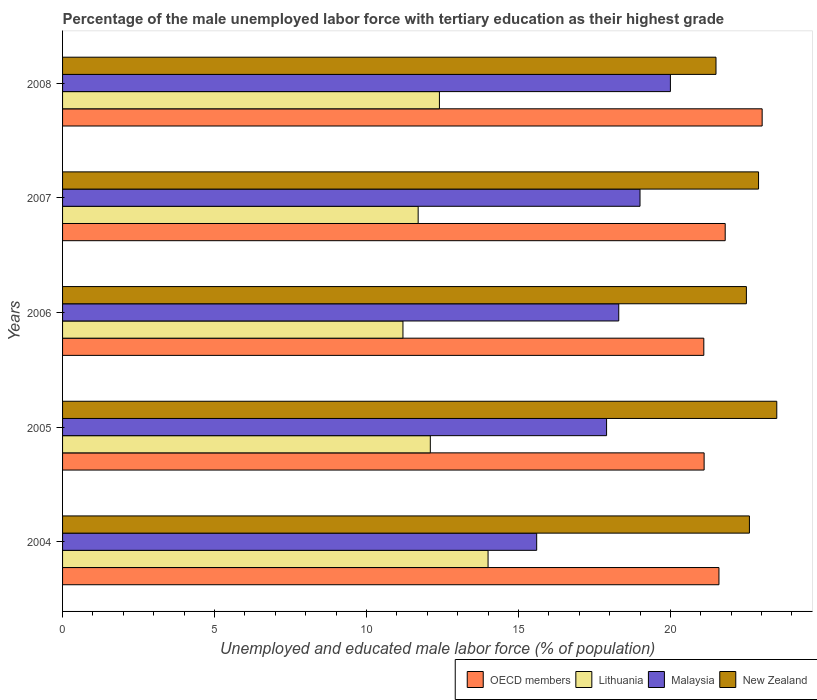How many different coloured bars are there?
Your answer should be compact. 4. Are the number of bars per tick equal to the number of legend labels?
Your response must be concise. Yes. How many bars are there on the 1st tick from the bottom?
Offer a very short reply. 4. What is the label of the 2nd group of bars from the top?
Make the answer very short. 2007. In how many cases, is the number of bars for a given year not equal to the number of legend labels?
Provide a short and direct response. 0. What is the percentage of the unemployed male labor force with tertiary education in Lithuania in 2005?
Provide a succinct answer. 12.1. In which year was the percentage of the unemployed male labor force with tertiary education in New Zealand maximum?
Provide a short and direct response. 2005. In which year was the percentage of the unemployed male labor force with tertiary education in OECD members minimum?
Your answer should be very brief. 2006. What is the total percentage of the unemployed male labor force with tertiary education in New Zealand in the graph?
Ensure brevity in your answer.  113. What is the difference between the percentage of the unemployed male labor force with tertiary education in Malaysia in 2004 and that in 2007?
Provide a succinct answer. -3.4. What is the difference between the percentage of the unemployed male labor force with tertiary education in OECD members in 2008 and the percentage of the unemployed male labor force with tertiary education in Lithuania in 2007?
Offer a terse response. 11.32. What is the average percentage of the unemployed male labor force with tertiary education in New Zealand per year?
Your response must be concise. 22.6. In the year 2005, what is the difference between the percentage of the unemployed male labor force with tertiary education in Lithuania and percentage of the unemployed male labor force with tertiary education in Malaysia?
Your response must be concise. -5.8. What is the ratio of the percentage of the unemployed male labor force with tertiary education in Lithuania in 2004 to that in 2006?
Provide a short and direct response. 1.25. Is the percentage of the unemployed male labor force with tertiary education in Lithuania in 2004 less than that in 2006?
Give a very brief answer. No. Is the difference between the percentage of the unemployed male labor force with tertiary education in Lithuania in 2004 and 2005 greater than the difference between the percentage of the unemployed male labor force with tertiary education in Malaysia in 2004 and 2005?
Provide a short and direct response. Yes. What is the difference between the highest and the second highest percentage of the unemployed male labor force with tertiary education in Lithuania?
Provide a succinct answer. 1.6. What is the difference between the highest and the lowest percentage of the unemployed male labor force with tertiary education in OECD members?
Your answer should be very brief. 1.92. What does the 1st bar from the top in 2006 represents?
Provide a short and direct response. New Zealand. What does the 3rd bar from the bottom in 2008 represents?
Offer a terse response. Malaysia. Are all the bars in the graph horizontal?
Provide a succinct answer. Yes. Are the values on the major ticks of X-axis written in scientific E-notation?
Your response must be concise. No. Does the graph contain any zero values?
Your answer should be very brief. No. Where does the legend appear in the graph?
Give a very brief answer. Bottom right. What is the title of the graph?
Your response must be concise. Percentage of the male unemployed labor force with tertiary education as their highest grade. What is the label or title of the X-axis?
Your answer should be compact. Unemployed and educated male labor force (% of population). What is the label or title of the Y-axis?
Make the answer very short. Years. What is the Unemployed and educated male labor force (% of population) of OECD members in 2004?
Keep it short and to the point. 21.6. What is the Unemployed and educated male labor force (% of population) of Malaysia in 2004?
Provide a succinct answer. 15.6. What is the Unemployed and educated male labor force (% of population) in New Zealand in 2004?
Ensure brevity in your answer.  22.6. What is the Unemployed and educated male labor force (% of population) in OECD members in 2005?
Your answer should be compact. 21.11. What is the Unemployed and educated male labor force (% of population) of Lithuania in 2005?
Provide a succinct answer. 12.1. What is the Unemployed and educated male labor force (% of population) of Malaysia in 2005?
Your answer should be very brief. 17.9. What is the Unemployed and educated male labor force (% of population) in OECD members in 2006?
Keep it short and to the point. 21.1. What is the Unemployed and educated male labor force (% of population) in Lithuania in 2006?
Provide a short and direct response. 11.2. What is the Unemployed and educated male labor force (% of population) of Malaysia in 2006?
Give a very brief answer. 18.3. What is the Unemployed and educated male labor force (% of population) in New Zealand in 2006?
Your answer should be very brief. 22.5. What is the Unemployed and educated male labor force (% of population) in OECD members in 2007?
Provide a short and direct response. 21.8. What is the Unemployed and educated male labor force (% of population) in Lithuania in 2007?
Make the answer very short. 11.7. What is the Unemployed and educated male labor force (% of population) in Malaysia in 2007?
Make the answer very short. 19. What is the Unemployed and educated male labor force (% of population) in New Zealand in 2007?
Keep it short and to the point. 22.9. What is the Unemployed and educated male labor force (% of population) in OECD members in 2008?
Offer a very short reply. 23.02. What is the Unemployed and educated male labor force (% of population) in Lithuania in 2008?
Your answer should be very brief. 12.4. What is the Unemployed and educated male labor force (% of population) in Malaysia in 2008?
Your answer should be compact. 20. Across all years, what is the maximum Unemployed and educated male labor force (% of population) of OECD members?
Provide a succinct answer. 23.02. Across all years, what is the maximum Unemployed and educated male labor force (% of population) in Lithuania?
Your answer should be very brief. 14. Across all years, what is the minimum Unemployed and educated male labor force (% of population) of OECD members?
Make the answer very short. 21.1. Across all years, what is the minimum Unemployed and educated male labor force (% of population) in Lithuania?
Your answer should be very brief. 11.2. Across all years, what is the minimum Unemployed and educated male labor force (% of population) in Malaysia?
Provide a succinct answer. 15.6. What is the total Unemployed and educated male labor force (% of population) of OECD members in the graph?
Give a very brief answer. 108.63. What is the total Unemployed and educated male labor force (% of population) in Lithuania in the graph?
Offer a very short reply. 61.4. What is the total Unemployed and educated male labor force (% of population) of Malaysia in the graph?
Keep it short and to the point. 90.8. What is the total Unemployed and educated male labor force (% of population) in New Zealand in the graph?
Provide a succinct answer. 113. What is the difference between the Unemployed and educated male labor force (% of population) in OECD members in 2004 and that in 2005?
Ensure brevity in your answer.  0.49. What is the difference between the Unemployed and educated male labor force (% of population) of Lithuania in 2004 and that in 2005?
Make the answer very short. 1.9. What is the difference between the Unemployed and educated male labor force (% of population) in OECD members in 2004 and that in 2006?
Your answer should be compact. 0.5. What is the difference between the Unemployed and educated male labor force (% of population) of Lithuania in 2004 and that in 2006?
Your response must be concise. 2.8. What is the difference between the Unemployed and educated male labor force (% of population) of New Zealand in 2004 and that in 2006?
Give a very brief answer. 0.1. What is the difference between the Unemployed and educated male labor force (% of population) of OECD members in 2004 and that in 2007?
Your response must be concise. -0.21. What is the difference between the Unemployed and educated male labor force (% of population) in Lithuania in 2004 and that in 2007?
Provide a succinct answer. 2.3. What is the difference between the Unemployed and educated male labor force (% of population) of OECD members in 2004 and that in 2008?
Make the answer very short. -1.42. What is the difference between the Unemployed and educated male labor force (% of population) in Lithuania in 2004 and that in 2008?
Offer a very short reply. 1.6. What is the difference between the Unemployed and educated male labor force (% of population) in New Zealand in 2004 and that in 2008?
Your response must be concise. 1.1. What is the difference between the Unemployed and educated male labor force (% of population) of OECD members in 2005 and that in 2006?
Provide a succinct answer. 0.01. What is the difference between the Unemployed and educated male labor force (% of population) of Lithuania in 2005 and that in 2006?
Offer a terse response. 0.9. What is the difference between the Unemployed and educated male labor force (% of population) of Malaysia in 2005 and that in 2006?
Give a very brief answer. -0.4. What is the difference between the Unemployed and educated male labor force (% of population) of New Zealand in 2005 and that in 2006?
Provide a short and direct response. 1. What is the difference between the Unemployed and educated male labor force (% of population) of OECD members in 2005 and that in 2007?
Provide a succinct answer. -0.69. What is the difference between the Unemployed and educated male labor force (% of population) in Malaysia in 2005 and that in 2007?
Your answer should be very brief. -1.1. What is the difference between the Unemployed and educated male labor force (% of population) in OECD members in 2005 and that in 2008?
Provide a short and direct response. -1.91. What is the difference between the Unemployed and educated male labor force (% of population) in Lithuania in 2005 and that in 2008?
Ensure brevity in your answer.  -0.3. What is the difference between the Unemployed and educated male labor force (% of population) of Malaysia in 2005 and that in 2008?
Offer a very short reply. -2.1. What is the difference between the Unemployed and educated male labor force (% of population) in OECD members in 2006 and that in 2007?
Ensure brevity in your answer.  -0.7. What is the difference between the Unemployed and educated male labor force (% of population) of Lithuania in 2006 and that in 2007?
Make the answer very short. -0.5. What is the difference between the Unemployed and educated male labor force (% of population) in New Zealand in 2006 and that in 2007?
Ensure brevity in your answer.  -0.4. What is the difference between the Unemployed and educated male labor force (% of population) of OECD members in 2006 and that in 2008?
Make the answer very short. -1.92. What is the difference between the Unemployed and educated male labor force (% of population) in Malaysia in 2006 and that in 2008?
Offer a very short reply. -1.7. What is the difference between the Unemployed and educated male labor force (% of population) of OECD members in 2007 and that in 2008?
Make the answer very short. -1.22. What is the difference between the Unemployed and educated male labor force (% of population) of OECD members in 2004 and the Unemployed and educated male labor force (% of population) of Lithuania in 2005?
Your answer should be compact. 9.5. What is the difference between the Unemployed and educated male labor force (% of population) in OECD members in 2004 and the Unemployed and educated male labor force (% of population) in Malaysia in 2005?
Offer a terse response. 3.7. What is the difference between the Unemployed and educated male labor force (% of population) in OECD members in 2004 and the Unemployed and educated male labor force (% of population) in New Zealand in 2005?
Ensure brevity in your answer.  -1.9. What is the difference between the Unemployed and educated male labor force (% of population) in Malaysia in 2004 and the Unemployed and educated male labor force (% of population) in New Zealand in 2005?
Make the answer very short. -7.9. What is the difference between the Unemployed and educated male labor force (% of population) of OECD members in 2004 and the Unemployed and educated male labor force (% of population) of Lithuania in 2006?
Ensure brevity in your answer.  10.4. What is the difference between the Unemployed and educated male labor force (% of population) in OECD members in 2004 and the Unemployed and educated male labor force (% of population) in Malaysia in 2006?
Ensure brevity in your answer.  3.3. What is the difference between the Unemployed and educated male labor force (% of population) in OECD members in 2004 and the Unemployed and educated male labor force (% of population) in New Zealand in 2006?
Your answer should be compact. -0.9. What is the difference between the Unemployed and educated male labor force (% of population) of Lithuania in 2004 and the Unemployed and educated male labor force (% of population) of New Zealand in 2006?
Offer a very short reply. -8.5. What is the difference between the Unemployed and educated male labor force (% of population) in Malaysia in 2004 and the Unemployed and educated male labor force (% of population) in New Zealand in 2006?
Give a very brief answer. -6.9. What is the difference between the Unemployed and educated male labor force (% of population) of OECD members in 2004 and the Unemployed and educated male labor force (% of population) of Lithuania in 2007?
Make the answer very short. 9.9. What is the difference between the Unemployed and educated male labor force (% of population) of OECD members in 2004 and the Unemployed and educated male labor force (% of population) of Malaysia in 2007?
Provide a succinct answer. 2.6. What is the difference between the Unemployed and educated male labor force (% of population) in OECD members in 2004 and the Unemployed and educated male labor force (% of population) in New Zealand in 2007?
Your response must be concise. -1.3. What is the difference between the Unemployed and educated male labor force (% of population) in Lithuania in 2004 and the Unemployed and educated male labor force (% of population) in New Zealand in 2007?
Offer a terse response. -8.9. What is the difference between the Unemployed and educated male labor force (% of population) of Malaysia in 2004 and the Unemployed and educated male labor force (% of population) of New Zealand in 2007?
Ensure brevity in your answer.  -7.3. What is the difference between the Unemployed and educated male labor force (% of population) of OECD members in 2004 and the Unemployed and educated male labor force (% of population) of Lithuania in 2008?
Make the answer very short. 9.2. What is the difference between the Unemployed and educated male labor force (% of population) of OECD members in 2004 and the Unemployed and educated male labor force (% of population) of Malaysia in 2008?
Make the answer very short. 1.6. What is the difference between the Unemployed and educated male labor force (% of population) in OECD members in 2004 and the Unemployed and educated male labor force (% of population) in New Zealand in 2008?
Provide a short and direct response. 0.1. What is the difference between the Unemployed and educated male labor force (% of population) in Lithuania in 2004 and the Unemployed and educated male labor force (% of population) in New Zealand in 2008?
Offer a terse response. -7.5. What is the difference between the Unemployed and educated male labor force (% of population) of OECD members in 2005 and the Unemployed and educated male labor force (% of population) of Lithuania in 2006?
Make the answer very short. 9.91. What is the difference between the Unemployed and educated male labor force (% of population) in OECD members in 2005 and the Unemployed and educated male labor force (% of population) in Malaysia in 2006?
Ensure brevity in your answer.  2.81. What is the difference between the Unemployed and educated male labor force (% of population) of OECD members in 2005 and the Unemployed and educated male labor force (% of population) of New Zealand in 2006?
Give a very brief answer. -1.39. What is the difference between the Unemployed and educated male labor force (% of population) in Malaysia in 2005 and the Unemployed and educated male labor force (% of population) in New Zealand in 2006?
Your answer should be compact. -4.6. What is the difference between the Unemployed and educated male labor force (% of population) in OECD members in 2005 and the Unemployed and educated male labor force (% of population) in Lithuania in 2007?
Offer a terse response. 9.41. What is the difference between the Unemployed and educated male labor force (% of population) in OECD members in 2005 and the Unemployed and educated male labor force (% of population) in Malaysia in 2007?
Offer a terse response. 2.11. What is the difference between the Unemployed and educated male labor force (% of population) in OECD members in 2005 and the Unemployed and educated male labor force (% of population) in New Zealand in 2007?
Ensure brevity in your answer.  -1.79. What is the difference between the Unemployed and educated male labor force (% of population) in Lithuania in 2005 and the Unemployed and educated male labor force (% of population) in Malaysia in 2007?
Your answer should be compact. -6.9. What is the difference between the Unemployed and educated male labor force (% of population) in Lithuania in 2005 and the Unemployed and educated male labor force (% of population) in New Zealand in 2007?
Make the answer very short. -10.8. What is the difference between the Unemployed and educated male labor force (% of population) in Malaysia in 2005 and the Unemployed and educated male labor force (% of population) in New Zealand in 2007?
Provide a succinct answer. -5. What is the difference between the Unemployed and educated male labor force (% of population) of OECD members in 2005 and the Unemployed and educated male labor force (% of population) of Lithuania in 2008?
Offer a very short reply. 8.71. What is the difference between the Unemployed and educated male labor force (% of population) of OECD members in 2005 and the Unemployed and educated male labor force (% of population) of Malaysia in 2008?
Provide a succinct answer. 1.11. What is the difference between the Unemployed and educated male labor force (% of population) of OECD members in 2005 and the Unemployed and educated male labor force (% of population) of New Zealand in 2008?
Offer a very short reply. -0.39. What is the difference between the Unemployed and educated male labor force (% of population) of Lithuania in 2005 and the Unemployed and educated male labor force (% of population) of Malaysia in 2008?
Offer a very short reply. -7.9. What is the difference between the Unemployed and educated male labor force (% of population) in Lithuania in 2005 and the Unemployed and educated male labor force (% of population) in New Zealand in 2008?
Your answer should be very brief. -9.4. What is the difference between the Unemployed and educated male labor force (% of population) in OECD members in 2006 and the Unemployed and educated male labor force (% of population) in Lithuania in 2007?
Provide a succinct answer. 9.4. What is the difference between the Unemployed and educated male labor force (% of population) of OECD members in 2006 and the Unemployed and educated male labor force (% of population) of Malaysia in 2007?
Keep it short and to the point. 2.1. What is the difference between the Unemployed and educated male labor force (% of population) in OECD members in 2006 and the Unemployed and educated male labor force (% of population) in New Zealand in 2007?
Your answer should be compact. -1.8. What is the difference between the Unemployed and educated male labor force (% of population) of Malaysia in 2006 and the Unemployed and educated male labor force (% of population) of New Zealand in 2007?
Keep it short and to the point. -4.6. What is the difference between the Unemployed and educated male labor force (% of population) in OECD members in 2006 and the Unemployed and educated male labor force (% of population) in Lithuania in 2008?
Your answer should be very brief. 8.7. What is the difference between the Unemployed and educated male labor force (% of population) in OECD members in 2006 and the Unemployed and educated male labor force (% of population) in Malaysia in 2008?
Offer a very short reply. 1.1. What is the difference between the Unemployed and educated male labor force (% of population) of OECD members in 2006 and the Unemployed and educated male labor force (% of population) of New Zealand in 2008?
Your answer should be compact. -0.4. What is the difference between the Unemployed and educated male labor force (% of population) in Lithuania in 2006 and the Unemployed and educated male labor force (% of population) in Malaysia in 2008?
Give a very brief answer. -8.8. What is the difference between the Unemployed and educated male labor force (% of population) in Malaysia in 2006 and the Unemployed and educated male labor force (% of population) in New Zealand in 2008?
Provide a short and direct response. -3.2. What is the difference between the Unemployed and educated male labor force (% of population) in OECD members in 2007 and the Unemployed and educated male labor force (% of population) in Lithuania in 2008?
Give a very brief answer. 9.4. What is the difference between the Unemployed and educated male labor force (% of population) of OECD members in 2007 and the Unemployed and educated male labor force (% of population) of Malaysia in 2008?
Keep it short and to the point. 1.8. What is the difference between the Unemployed and educated male labor force (% of population) of OECD members in 2007 and the Unemployed and educated male labor force (% of population) of New Zealand in 2008?
Offer a terse response. 0.3. What is the difference between the Unemployed and educated male labor force (% of population) of Lithuania in 2007 and the Unemployed and educated male labor force (% of population) of New Zealand in 2008?
Give a very brief answer. -9.8. What is the average Unemployed and educated male labor force (% of population) in OECD members per year?
Provide a succinct answer. 21.73. What is the average Unemployed and educated male labor force (% of population) of Lithuania per year?
Your answer should be compact. 12.28. What is the average Unemployed and educated male labor force (% of population) of Malaysia per year?
Provide a short and direct response. 18.16. What is the average Unemployed and educated male labor force (% of population) in New Zealand per year?
Your answer should be compact. 22.6. In the year 2004, what is the difference between the Unemployed and educated male labor force (% of population) in OECD members and Unemployed and educated male labor force (% of population) in Lithuania?
Your answer should be very brief. 7.6. In the year 2004, what is the difference between the Unemployed and educated male labor force (% of population) in OECD members and Unemployed and educated male labor force (% of population) in Malaysia?
Your answer should be compact. 6. In the year 2004, what is the difference between the Unemployed and educated male labor force (% of population) in OECD members and Unemployed and educated male labor force (% of population) in New Zealand?
Ensure brevity in your answer.  -1. In the year 2004, what is the difference between the Unemployed and educated male labor force (% of population) of Lithuania and Unemployed and educated male labor force (% of population) of New Zealand?
Your response must be concise. -8.6. In the year 2004, what is the difference between the Unemployed and educated male labor force (% of population) in Malaysia and Unemployed and educated male labor force (% of population) in New Zealand?
Your answer should be very brief. -7. In the year 2005, what is the difference between the Unemployed and educated male labor force (% of population) in OECD members and Unemployed and educated male labor force (% of population) in Lithuania?
Ensure brevity in your answer.  9.01. In the year 2005, what is the difference between the Unemployed and educated male labor force (% of population) in OECD members and Unemployed and educated male labor force (% of population) in Malaysia?
Your answer should be very brief. 3.21. In the year 2005, what is the difference between the Unemployed and educated male labor force (% of population) of OECD members and Unemployed and educated male labor force (% of population) of New Zealand?
Your answer should be compact. -2.39. In the year 2005, what is the difference between the Unemployed and educated male labor force (% of population) of Malaysia and Unemployed and educated male labor force (% of population) of New Zealand?
Keep it short and to the point. -5.6. In the year 2006, what is the difference between the Unemployed and educated male labor force (% of population) in OECD members and Unemployed and educated male labor force (% of population) in Lithuania?
Your answer should be compact. 9.9. In the year 2006, what is the difference between the Unemployed and educated male labor force (% of population) of OECD members and Unemployed and educated male labor force (% of population) of Malaysia?
Your answer should be compact. 2.8. In the year 2006, what is the difference between the Unemployed and educated male labor force (% of population) of OECD members and Unemployed and educated male labor force (% of population) of New Zealand?
Offer a terse response. -1.4. In the year 2006, what is the difference between the Unemployed and educated male labor force (% of population) of Lithuania and Unemployed and educated male labor force (% of population) of New Zealand?
Your response must be concise. -11.3. In the year 2007, what is the difference between the Unemployed and educated male labor force (% of population) in OECD members and Unemployed and educated male labor force (% of population) in Lithuania?
Keep it short and to the point. 10.1. In the year 2007, what is the difference between the Unemployed and educated male labor force (% of population) of OECD members and Unemployed and educated male labor force (% of population) of Malaysia?
Offer a terse response. 2.8. In the year 2007, what is the difference between the Unemployed and educated male labor force (% of population) in OECD members and Unemployed and educated male labor force (% of population) in New Zealand?
Provide a short and direct response. -1.1. In the year 2007, what is the difference between the Unemployed and educated male labor force (% of population) of Malaysia and Unemployed and educated male labor force (% of population) of New Zealand?
Keep it short and to the point. -3.9. In the year 2008, what is the difference between the Unemployed and educated male labor force (% of population) in OECD members and Unemployed and educated male labor force (% of population) in Lithuania?
Ensure brevity in your answer.  10.62. In the year 2008, what is the difference between the Unemployed and educated male labor force (% of population) in OECD members and Unemployed and educated male labor force (% of population) in Malaysia?
Offer a very short reply. 3.02. In the year 2008, what is the difference between the Unemployed and educated male labor force (% of population) of OECD members and Unemployed and educated male labor force (% of population) of New Zealand?
Your answer should be very brief. 1.52. What is the ratio of the Unemployed and educated male labor force (% of population) in OECD members in 2004 to that in 2005?
Provide a succinct answer. 1.02. What is the ratio of the Unemployed and educated male labor force (% of population) in Lithuania in 2004 to that in 2005?
Provide a succinct answer. 1.16. What is the ratio of the Unemployed and educated male labor force (% of population) in Malaysia in 2004 to that in 2005?
Your answer should be very brief. 0.87. What is the ratio of the Unemployed and educated male labor force (% of population) of New Zealand in 2004 to that in 2005?
Offer a very short reply. 0.96. What is the ratio of the Unemployed and educated male labor force (% of population) in OECD members in 2004 to that in 2006?
Give a very brief answer. 1.02. What is the ratio of the Unemployed and educated male labor force (% of population) of Malaysia in 2004 to that in 2006?
Ensure brevity in your answer.  0.85. What is the ratio of the Unemployed and educated male labor force (% of population) of OECD members in 2004 to that in 2007?
Keep it short and to the point. 0.99. What is the ratio of the Unemployed and educated male labor force (% of population) in Lithuania in 2004 to that in 2007?
Offer a terse response. 1.2. What is the ratio of the Unemployed and educated male labor force (% of population) in Malaysia in 2004 to that in 2007?
Your response must be concise. 0.82. What is the ratio of the Unemployed and educated male labor force (% of population) of New Zealand in 2004 to that in 2007?
Your answer should be very brief. 0.99. What is the ratio of the Unemployed and educated male labor force (% of population) of OECD members in 2004 to that in 2008?
Your answer should be very brief. 0.94. What is the ratio of the Unemployed and educated male labor force (% of population) of Lithuania in 2004 to that in 2008?
Offer a terse response. 1.13. What is the ratio of the Unemployed and educated male labor force (% of population) of Malaysia in 2004 to that in 2008?
Offer a terse response. 0.78. What is the ratio of the Unemployed and educated male labor force (% of population) in New Zealand in 2004 to that in 2008?
Your response must be concise. 1.05. What is the ratio of the Unemployed and educated male labor force (% of population) in Lithuania in 2005 to that in 2006?
Your response must be concise. 1.08. What is the ratio of the Unemployed and educated male labor force (% of population) in Malaysia in 2005 to that in 2006?
Give a very brief answer. 0.98. What is the ratio of the Unemployed and educated male labor force (% of population) of New Zealand in 2005 to that in 2006?
Your answer should be compact. 1.04. What is the ratio of the Unemployed and educated male labor force (% of population) in OECD members in 2005 to that in 2007?
Give a very brief answer. 0.97. What is the ratio of the Unemployed and educated male labor force (% of population) in Lithuania in 2005 to that in 2007?
Give a very brief answer. 1.03. What is the ratio of the Unemployed and educated male labor force (% of population) of Malaysia in 2005 to that in 2007?
Offer a very short reply. 0.94. What is the ratio of the Unemployed and educated male labor force (% of population) in New Zealand in 2005 to that in 2007?
Provide a succinct answer. 1.03. What is the ratio of the Unemployed and educated male labor force (% of population) in OECD members in 2005 to that in 2008?
Your answer should be very brief. 0.92. What is the ratio of the Unemployed and educated male labor force (% of population) in Lithuania in 2005 to that in 2008?
Ensure brevity in your answer.  0.98. What is the ratio of the Unemployed and educated male labor force (% of population) in Malaysia in 2005 to that in 2008?
Give a very brief answer. 0.9. What is the ratio of the Unemployed and educated male labor force (% of population) in New Zealand in 2005 to that in 2008?
Your answer should be very brief. 1.09. What is the ratio of the Unemployed and educated male labor force (% of population) of OECD members in 2006 to that in 2007?
Offer a very short reply. 0.97. What is the ratio of the Unemployed and educated male labor force (% of population) of Lithuania in 2006 to that in 2007?
Your answer should be very brief. 0.96. What is the ratio of the Unemployed and educated male labor force (% of population) in Malaysia in 2006 to that in 2007?
Keep it short and to the point. 0.96. What is the ratio of the Unemployed and educated male labor force (% of population) in New Zealand in 2006 to that in 2007?
Give a very brief answer. 0.98. What is the ratio of the Unemployed and educated male labor force (% of population) of OECD members in 2006 to that in 2008?
Offer a very short reply. 0.92. What is the ratio of the Unemployed and educated male labor force (% of population) of Lithuania in 2006 to that in 2008?
Make the answer very short. 0.9. What is the ratio of the Unemployed and educated male labor force (% of population) of Malaysia in 2006 to that in 2008?
Your answer should be compact. 0.92. What is the ratio of the Unemployed and educated male labor force (% of population) in New Zealand in 2006 to that in 2008?
Keep it short and to the point. 1.05. What is the ratio of the Unemployed and educated male labor force (% of population) of OECD members in 2007 to that in 2008?
Give a very brief answer. 0.95. What is the ratio of the Unemployed and educated male labor force (% of population) in Lithuania in 2007 to that in 2008?
Give a very brief answer. 0.94. What is the ratio of the Unemployed and educated male labor force (% of population) of Malaysia in 2007 to that in 2008?
Provide a short and direct response. 0.95. What is the ratio of the Unemployed and educated male labor force (% of population) in New Zealand in 2007 to that in 2008?
Give a very brief answer. 1.07. What is the difference between the highest and the second highest Unemployed and educated male labor force (% of population) in OECD members?
Ensure brevity in your answer.  1.22. What is the difference between the highest and the second highest Unemployed and educated male labor force (% of population) of Lithuania?
Your response must be concise. 1.6. What is the difference between the highest and the second highest Unemployed and educated male labor force (% of population) of New Zealand?
Give a very brief answer. 0.6. What is the difference between the highest and the lowest Unemployed and educated male labor force (% of population) of OECD members?
Provide a succinct answer. 1.92. What is the difference between the highest and the lowest Unemployed and educated male labor force (% of population) of Malaysia?
Your response must be concise. 4.4. 